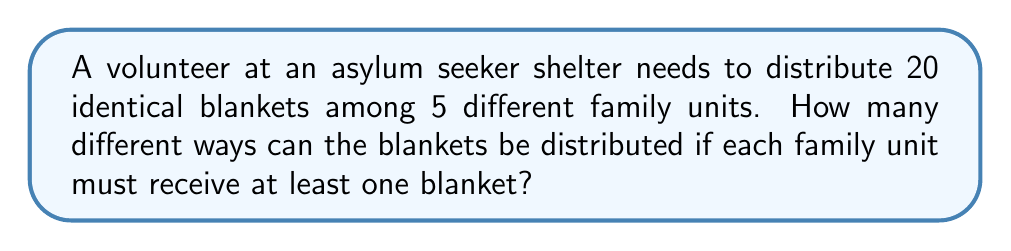Show me your answer to this math problem. Let's approach this step-by-step:

1) This is a problem of distributing identical objects (blankets) into distinct boxes (family units). We can use the concept of stars and bars (or balls and urns) from combinatorics.

2) We need to distribute 20 blankets, but each family must receive at least one. So, we first give one blanket to each family, leaving 15 blankets to distribute freely.

3) Now we have 15 blankets to distribute among 5 families, with no restrictions. This is equivalent to choosing 4 dividers to place among 15 stars.

4) The formula for this scenario is:

   $$\binom{n+k-1}{k-1}$$

   Where $n$ is the number of identical objects (remaining blankets) and $k$ is the number of distinct boxes (families).

5) In our case, $n = 15$ and $k = 5$. So we calculate:

   $$\binom{15+5-1}{5-1} = \binom{19}{4}$$

6) We can calculate this as:

   $$\binom{19}{4} = \frac{19!}{4!(19-4)!} = \frac{19!}{4!15!}$$

7) Simplifying:

   $$\frac{19 \cdot 18 \cdot 17 \cdot 16}{4 \cdot 3 \cdot 2 \cdot 1} = 3876$$

Therefore, there are 3876 different ways to distribute the blankets.
Answer: 3876 